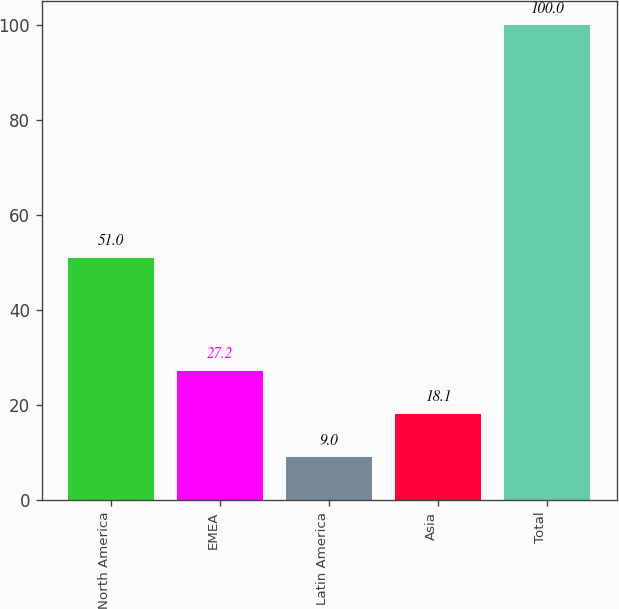<chart> <loc_0><loc_0><loc_500><loc_500><bar_chart><fcel>North America<fcel>EMEA<fcel>Latin America<fcel>Asia<fcel>Total<nl><fcel>51<fcel>27.2<fcel>9<fcel>18.1<fcel>100<nl></chart> 